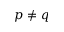<formula> <loc_0><loc_0><loc_500><loc_500>p \neq q</formula> 